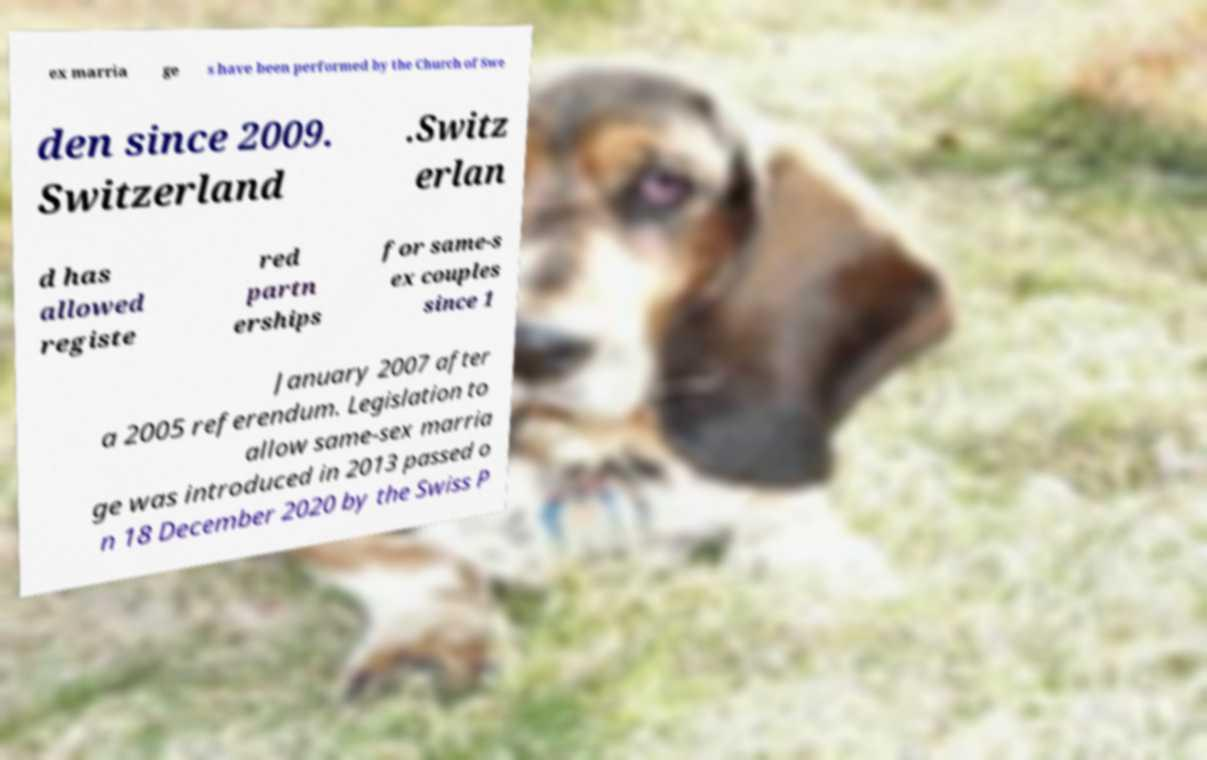Please read and relay the text visible in this image. What does it say? ex marria ge s have been performed by the Church of Swe den since 2009. Switzerland .Switz erlan d has allowed registe red partn erships for same-s ex couples since 1 January 2007 after a 2005 referendum. Legislation to allow same-sex marria ge was introduced in 2013 passed o n 18 December 2020 by the Swiss P 